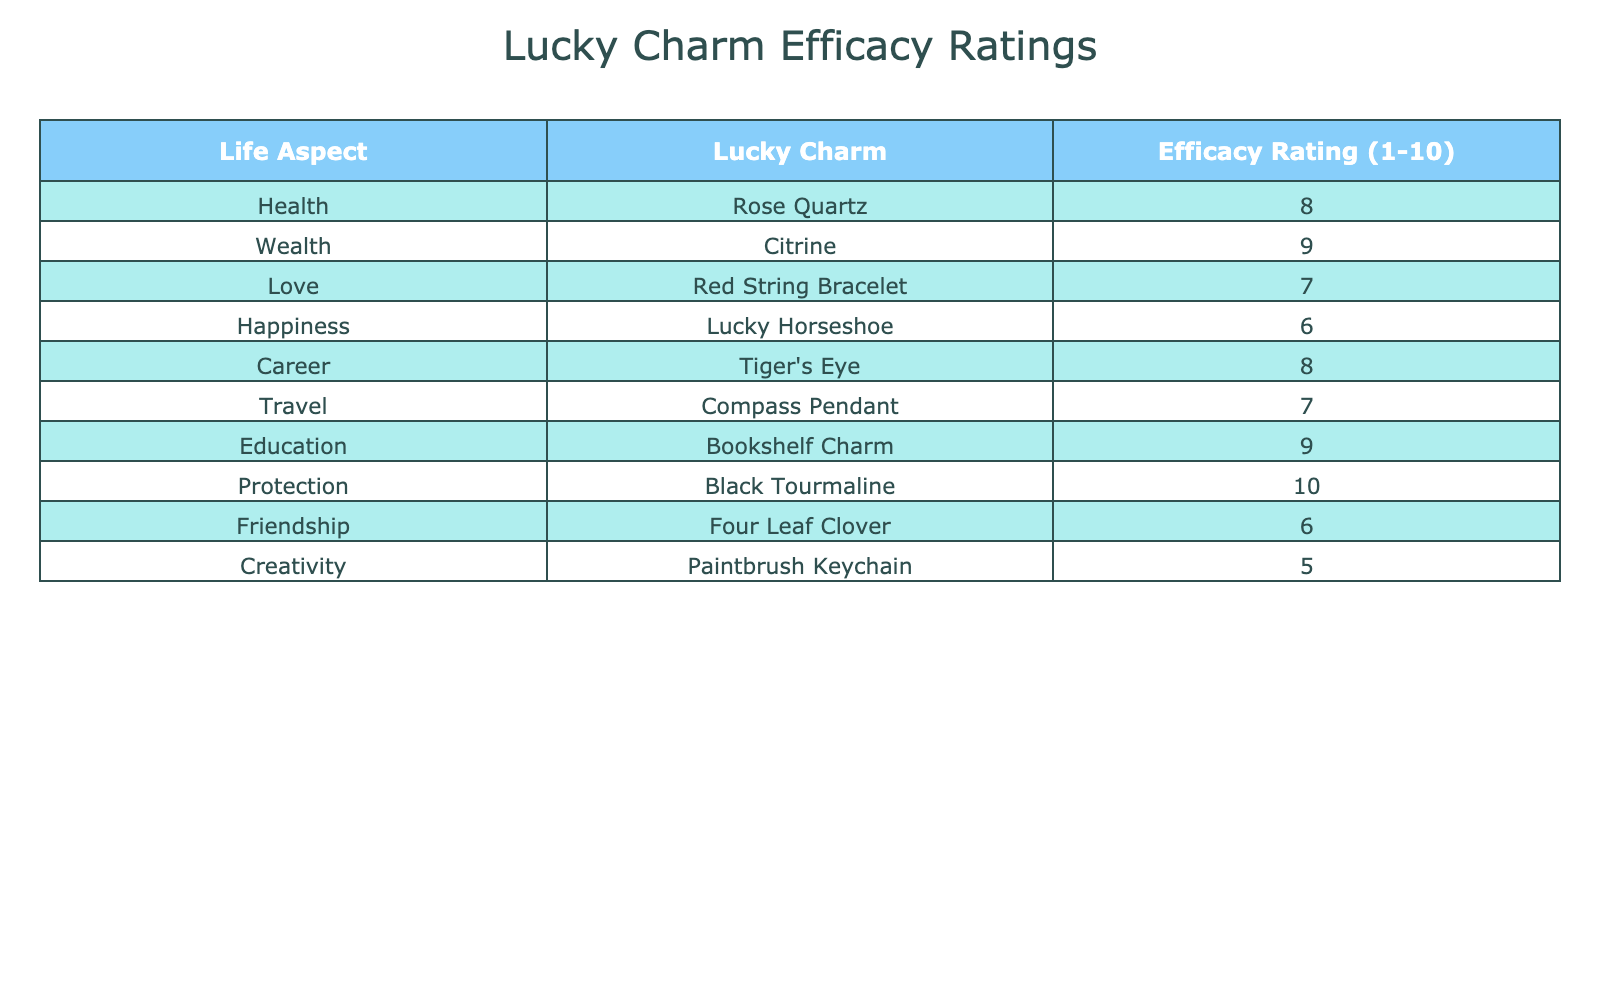What is the efficacy rating for the Rose Quartz? The table lists the efficacy rating for the Rose Quartz as 8 under the Health aspect.
Answer: 8 What is the highest efficacy rating among all the lucky charms? The ratings for each charm are reviewed, and the highest rating is 10 for the Black Tourmaline used for Protection.
Answer: 10 Are there any lucky charms with an efficacy rating below 6? The lucky charms for Happiness and Creativity have ratings of 6 and 5, respectively, indicating there are charms rated below 6.
Answer: Yes What is the average efficacy rating for lucky charms related to emotional aspects like Love and Happiness? The ratings for Love (7) and Happiness (6) are averaged, resulting in (7 + 6) / 2 = 6.5.
Answer: 6.5 Which life aspect has the lowest efficacy rating and what is that rating? After checking all the ratings, the Paintbrush Keychain for Creativity has the lowest rating of 5.
Answer: Creativity, 5 How many lucky charms have an efficacy rating of 8 or above? The charms with ratings of 8 or above are Rose Quartz (8), Citrine (9), Bookshelf Charm (9), Education (9), and Black Tourmaline (10), totaling 5 charms.
Answer: 5 Which lucky charm is rated highest for both Travel and Happiness, and what are their ratings? The Compass Pendant for Travel is rated 7, and the Lucky Horseshoe for Happiness is rated 6; neither charm has the highest rating.
Answer: None Is the efficacy rating of the Tiger's Eye for Career higher than the Red String Bracelet for Love? The Tiger's Eye is rated 8 for Career while the Red String Bracelet is rated 7 for Love; therefore, the rating for Tiger's Eye is indeed higher.
Answer: Yes 